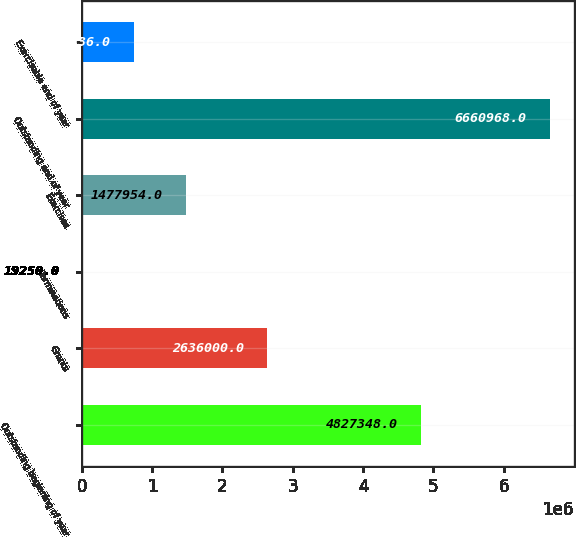Convert chart. <chart><loc_0><loc_0><loc_500><loc_500><bar_chart><fcel>Outstanding beginning of year<fcel>Grants<fcel>Terminations<fcel>Exercises<fcel>Outstanding end of year<fcel>Exercisable end of year<nl><fcel>4.82735e+06<fcel>2.636e+06<fcel>19250<fcel>1.47795e+06<fcel>6.66097e+06<fcel>745336<nl></chart> 